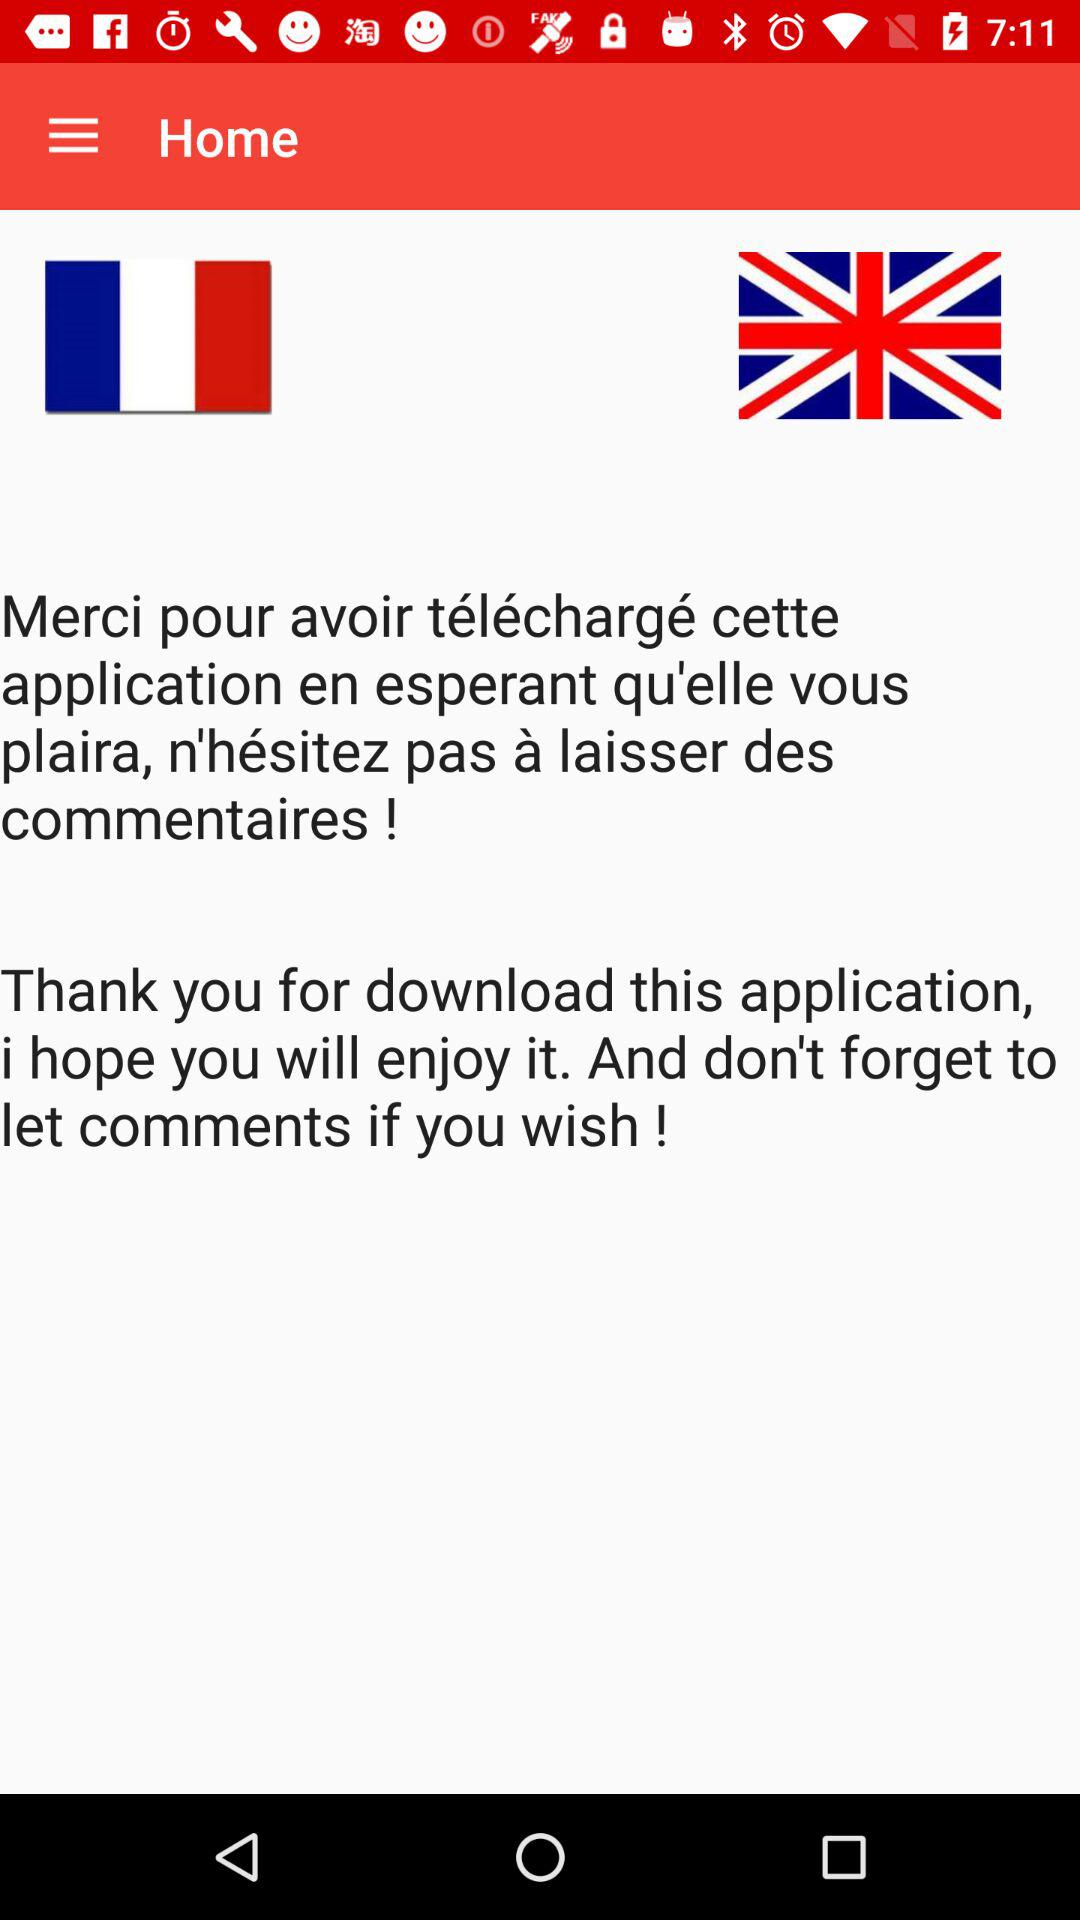How many languages are supported by the application?
Answer the question using a single word or phrase. 2 